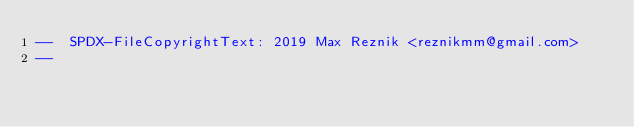<code> <loc_0><loc_0><loc_500><loc_500><_Ada_>--  SPDX-FileCopyrightText: 2019 Max Reznik <reznikmm@gmail.com>
--</code> 